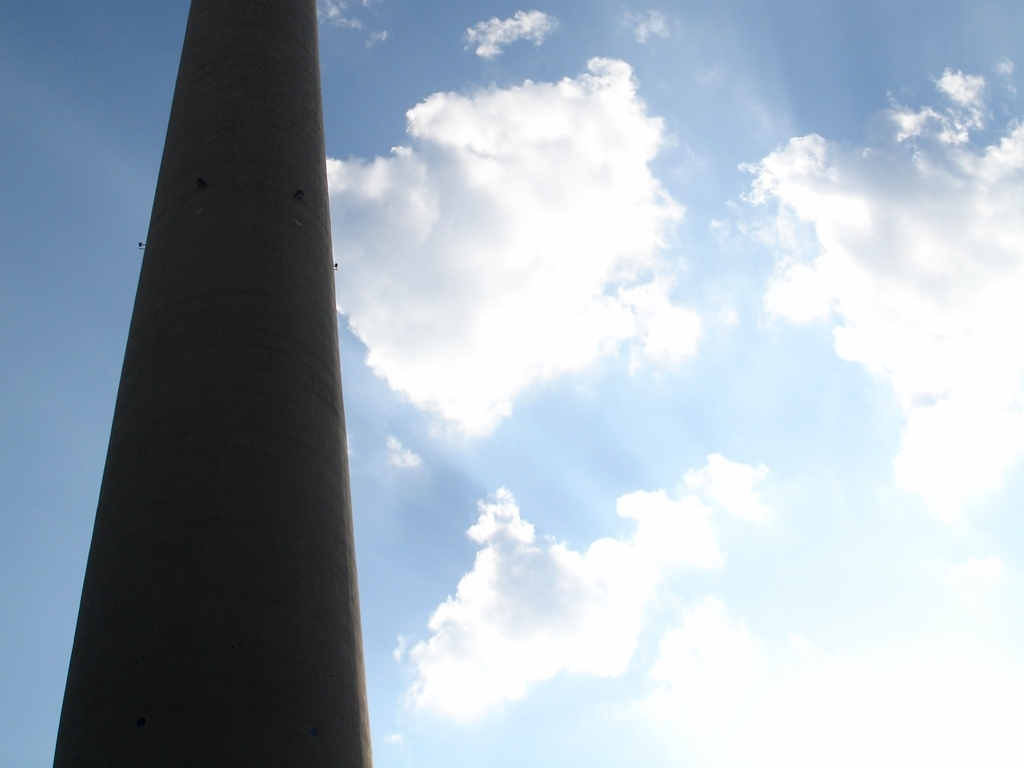Does the photo lack sharpness?
A. Yes
B. No
Answer with the option's letter from the given choices directly.
 B. 